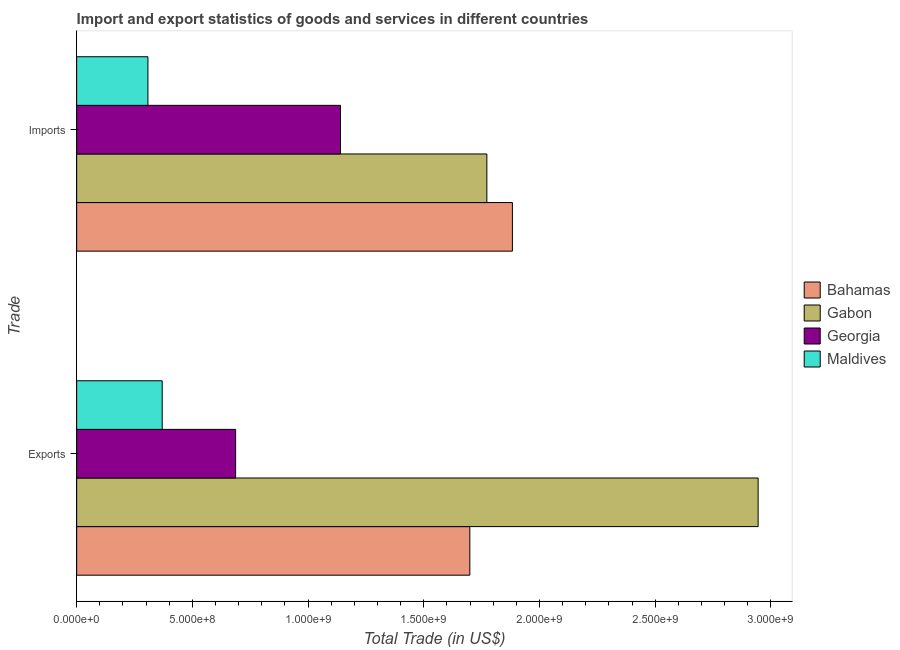How many different coloured bars are there?
Offer a very short reply. 4. How many groups of bars are there?
Your answer should be compact. 2. How many bars are there on the 1st tick from the top?
Provide a succinct answer. 4. How many bars are there on the 2nd tick from the bottom?
Your answer should be very brief. 4. What is the label of the 1st group of bars from the top?
Offer a very short reply. Imports. What is the imports of goods and services in Gabon?
Make the answer very short. 1.77e+09. Across all countries, what is the maximum export of goods and services?
Provide a short and direct response. 2.94e+09. Across all countries, what is the minimum export of goods and services?
Ensure brevity in your answer.  3.70e+08. In which country was the imports of goods and services maximum?
Ensure brevity in your answer.  Bahamas. In which country was the export of goods and services minimum?
Give a very brief answer. Maldives. What is the total imports of goods and services in the graph?
Give a very brief answer. 5.10e+09. What is the difference between the export of goods and services in Maldives and that in Gabon?
Make the answer very short. -2.58e+09. What is the difference between the imports of goods and services in Maldives and the export of goods and services in Bahamas?
Offer a very short reply. -1.39e+09. What is the average imports of goods and services per country?
Make the answer very short. 1.28e+09. What is the difference between the imports of goods and services and export of goods and services in Maldives?
Your answer should be compact. -6.17e+07. What is the ratio of the export of goods and services in Gabon to that in Georgia?
Make the answer very short. 4.29. Is the imports of goods and services in Georgia less than that in Bahamas?
Offer a terse response. Yes. In how many countries, is the imports of goods and services greater than the average imports of goods and services taken over all countries?
Offer a very short reply. 2. What does the 1st bar from the top in Imports represents?
Your answer should be compact. Maldives. What does the 4th bar from the bottom in Imports represents?
Your answer should be very brief. Maldives. What is the difference between two consecutive major ticks on the X-axis?
Keep it short and to the point. 5.00e+08. Does the graph contain any zero values?
Your answer should be very brief. No. How many legend labels are there?
Provide a succinct answer. 4. What is the title of the graph?
Your response must be concise. Import and export statistics of goods and services in different countries. Does "Cambodia" appear as one of the legend labels in the graph?
Keep it short and to the point. No. What is the label or title of the X-axis?
Give a very brief answer. Total Trade (in US$). What is the label or title of the Y-axis?
Offer a very short reply. Trade. What is the Total Trade (in US$) in Bahamas in Exports?
Provide a short and direct response. 1.70e+09. What is the Total Trade (in US$) in Gabon in Exports?
Provide a succinct answer. 2.94e+09. What is the Total Trade (in US$) in Georgia in Exports?
Provide a short and direct response. 6.87e+08. What is the Total Trade (in US$) of Maldives in Exports?
Keep it short and to the point. 3.70e+08. What is the Total Trade (in US$) in Bahamas in Imports?
Make the answer very short. 1.88e+09. What is the Total Trade (in US$) in Gabon in Imports?
Offer a terse response. 1.77e+09. What is the Total Trade (in US$) of Georgia in Imports?
Your response must be concise. 1.14e+09. What is the Total Trade (in US$) of Maldives in Imports?
Give a very brief answer. 3.08e+08. Across all Trade, what is the maximum Total Trade (in US$) in Bahamas?
Provide a succinct answer. 1.88e+09. Across all Trade, what is the maximum Total Trade (in US$) in Gabon?
Make the answer very short. 2.94e+09. Across all Trade, what is the maximum Total Trade (in US$) of Georgia?
Give a very brief answer. 1.14e+09. Across all Trade, what is the maximum Total Trade (in US$) of Maldives?
Ensure brevity in your answer.  3.70e+08. Across all Trade, what is the minimum Total Trade (in US$) in Bahamas?
Ensure brevity in your answer.  1.70e+09. Across all Trade, what is the minimum Total Trade (in US$) of Gabon?
Your answer should be very brief. 1.77e+09. Across all Trade, what is the minimum Total Trade (in US$) in Georgia?
Offer a terse response. 6.87e+08. Across all Trade, what is the minimum Total Trade (in US$) of Maldives?
Offer a very short reply. 3.08e+08. What is the total Total Trade (in US$) of Bahamas in the graph?
Ensure brevity in your answer.  3.58e+09. What is the total Total Trade (in US$) of Gabon in the graph?
Make the answer very short. 4.72e+09. What is the total Total Trade (in US$) in Georgia in the graph?
Provide a short and direct response. 1.83e+09. What is the total Total Trade (in US$) of Maldives in the graph?
Keep it short and to the point. 6.78e+08. What is the difference between the Total Trade (in US$) of Bahamas in Exports and that in Imports?
Keep it short and to the point. -1.84e+08. What is the difference between the Total Trade (in US$) of Gabon in Exports and that in Imports?
Provide a succinct answer. 1.17e+09. What is the difference between the Total Trade (in US$) of Georgia in Exports and that in Imports?
Ensure brevity in your answer.  -4.53e+08. What is the difference between the Total Trade (in US$) in Maldives in Exports and that in Imports?
Ensure brevity in your answer.  6.17e+07. What is the difference between the Total Trade (in US$) of Bahamas in Exports and the Total Trade (in US$) of Gabon in Imports?
Your response must be concise. -7.36e+07. What is the difference between the Total Trade (in US$) in Bahamas in Exports and the Total Trade (in US$) in Georgia in Imports?
Give a very brief answer. 5.59e+08. What is the difference between the Total Trade (in US$) in Bahamas in Exports and the Total Trade (in US$) in Maldives in Imports?
Your answer should be compact. 1.39e+09. What is the difference between the Total Trade (in US$) of Gabon in Exports and the Total Trade (in US$) of Georgia in Imports?
Make the answer very short. 1.80e+09. What is the difference between the Total Trade (in US$) of Gabon in Exports and the Total Trade (in US$) of Maldives in Imports?
Offer a terse response. 2.64e+09. What is the difference between the Total Trade (in US$) in Georgia in Exports and the Total Trade (in US$) in Maldives in Imports?
Make the answer very short. 3.79e+08. What is the average Total Trade (in US$) in Bahamas per Trade?
Provide a short and direct response. 1.79e+09. What is the average Total Trade (in US$) of Gabon per Trade?
Your response must be concise. 2.36e+09. What is the average Total Trade (in US$) in Georgia per Trade?
Provide a short and direct response. 9.14e+08. What is the average Total Trade (in US$) of Maldives per Trade?
Offer a terse response. 3.39e+08. What is the difference between the Total Trade (in US$) of Bahamas and Total Trade (in US$) of Gabon in Exports?
Your response must be concise. -1.25e+09. What is the difference between the Total Trade (in US$) of Bahamas and Total Trade (in US$) of Georgia in Exports?
Your answer should be compact. 1.01e+09. What is the difference between the Total Trade (in US$) in Bahamas and Total Trade (in US$) in Maldives in Exports?
Your response must be concise. 1.33e+09. What is the difference between the Total Trade (in US$) in Gabon and Total Trade (in US$) in Georgia in Exports?
Make the answer very short. 2.26e+09. What is the difference between the Total Trade (in US$) of Gabon and Total Trade (in US$) of Maldives in Exports?
Offer a very short reply. 2.58e+09. What is the difference between the Total Trade (in US$) of Georgia and Total Trade (in US$) of Maldives in Exports?
Keep it short and to the point. 3.17e+08. What is the difference between the Total Trade (in US$) in Bahamas and Total Trade (in US$) in Gabon in Imports?
Offer a very short reply. 1.10e+08. What is the difference between the Total Trade (in US$) of Bahamas and Total Trade (in US$) of Georgia in Imports?
Your answer should be compact. 7.43e+08. What is the difference between the Total Trade (in US$) in Bahamas and Total Trade (in US$) in Maldives in Imports?
Offer a terse response. 1.58e+09. What is the difference between the Total Trade (in US$) in Gabon and Total Trade (in US$) in Georgia in Imports?
Make the answer very short. 6.33e+08. What is the difference between the Total Trade (in US$) in Gabon and Total Trade (in US$) in Maldives in Imports?
Your response must be concise. 1.46e+09. What is the difference between the Total Trade (in US$) in Georgia and Total Trade (in US$) in Maldives in Imports?
Make the answer very short. 8.32e+08. What is the ratio of the Total Trade (in US$) of Bahamas in Exports to that in Imports?
Give a very brief answer. 0.9. What is the ratio of the Total Trade (in US$) in Gabon in Exports to that in Imports?
Ensure brevity in your answer.  1.66. What is the ratio of the Total Trade (in US$) in Georgia in Exports to that in Imports?
Offer a terse response. 0.6. What is the ratio of the Total Trade (in US$) of Maldives in Exports to that in Imports?
Offer a terse response. 1.2. What is the difference between the highest and the second highest Total Trade (in US$) of Bahamas?
Give a very brief answer. 1.84e+08. What is the difference between the highest and the second highest Total Trade (in US$) of Gabon?
Keep it short and to the point. 1.17e+09. What is the difference between the highest and the second highest Total Trade (in US$) in Georgia?
Offer a terse response. 4.53e+08. What is the difference between the highest and the second highest Total Trade (in US$) in Maldives?
Give a very brief answer. 6.17e+07. What is the difference between the highest and the lowest Total Trade (in US$) in Bahamas?
Ensure brevity in your answer.  1.84e+08. What is the difference between the highest and the lowest Total Trade (in US$) in Gabon?
Your answer should be compact. 1.17e+09. What is the difference between the highest and the lowest Total Trade (in US$) in Georgia?
Make the answer very short. 4.53e+08. What is the difference between the highest and the lowest Total Trade (in US$) in Maldives?
Ensure brevity in your answer.  6.17e+07. 